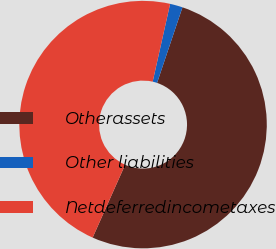Convert chart to OTSL. <chart><loc_0><loc_0><loc_500><loc_500><pie_chart><fcel>Otherassets<fcel>Other liabilities<fcel>Netdeferredincometaxes<nl><fcel>51.52%<fcel>1.65%<fcel>46.84%<nl></chart> 